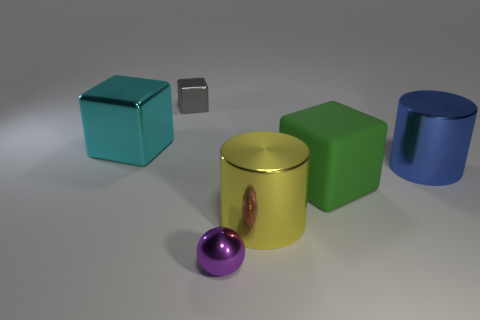Are there any other things that have the same material as the big green block?
Ensure brevity in your answer.  No. There is a block that is behind the cyan block; is there a metal cylinder behind it?
Give a very brief answer. No. Is there a blue metallic thing?
Provide a succinct answer. Yes. There is a small thing in front of the small thing behind the cyan metallic block; what is its color?
Your answer should be compact. Purple. There is a green thing that is the same shape as the tiny gray thing; what material is it?
Make the answer very short. Rubber. How many matte things are the same size as the purple ball?
Ensure brevity in your answer.  0. What size is the yellow object that is made of the same material as the large cyan cube?
Provide a short and direct response. Large. What number of blue metal things are the same shape as the small gray metal thing?
Offer a very short reply. 0. What number of big cyan metal blocks are there?
Provide a short and direct response. 1. Does the metallic object left of the gray thing have the same shape as the gray thing?
Give a very brief answer. Yes. 